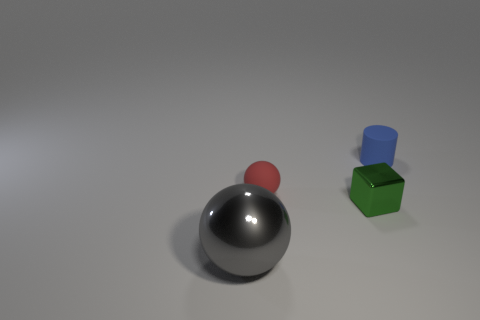What is the size of the other object that is the same shape as the large object?
Offer a very short reply. Small. Is the number of big gray spheres in front of the rubber cylinder less than the number of gray shiny objects on the right side of the small green shiny cube?
Provide a short and direct response. No. What shape is the object that is to the left of the tiny block and behind the green block?
Keep it short and to the point. Sphere. What size is the red sphere that is the same material as the cylinder?
Give a very brief answer. Small. What is the object that is both to the left of the small green object and behind the gray metal object made of?
Your response must be concise. Rubber. Does the object to the left of the tiny ball have the same shape as the small rubber object left of the green metallic object?
Your answer should be very brief. Yes. Are any purple matte objects visible?
Your answer should be very brief. No. What color is the other metallic thing that is the same shape as the small red object?
Offer a terse response. Gray. There is a metal cube that is the same size as the blue matte thing; what is its color?
Give a very brief answer. Green. Is the small green cube made of the same material as the cylinder?
Ensure brevity in your answer.  No. 